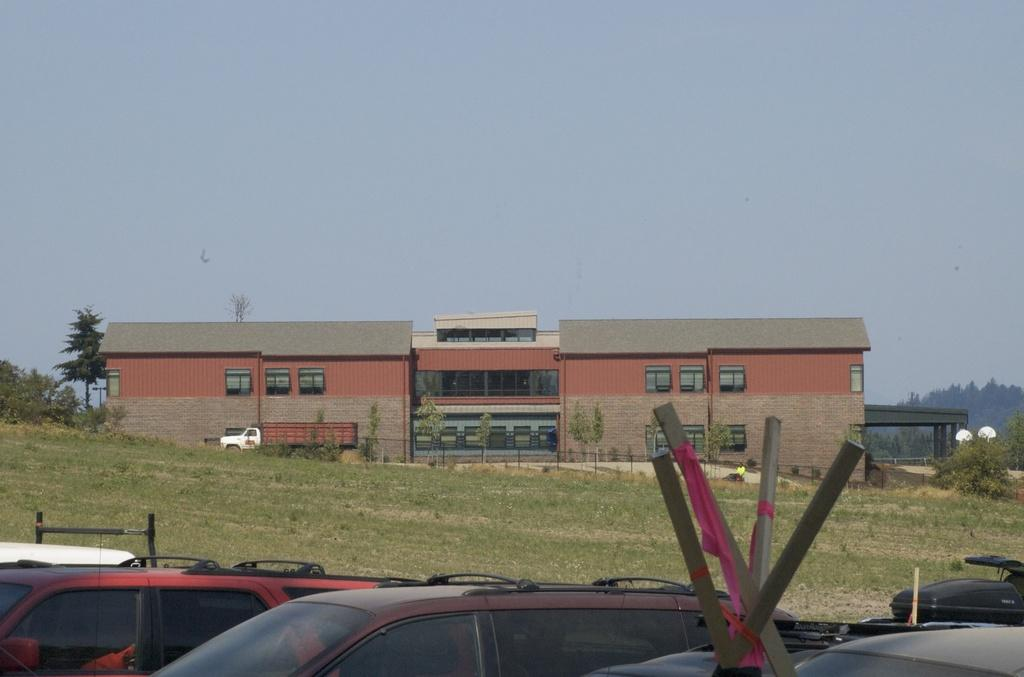What types of objects are present in the image? There are vehicles in the image. What type of natural environment can be seen in the image? There is grass visible in the image. What can be seen in the background of the image? There is a building, trees, and the sky visible in the background of the image. What type of dress is being copied in the image? There is no dress or copying activity present in the image. 